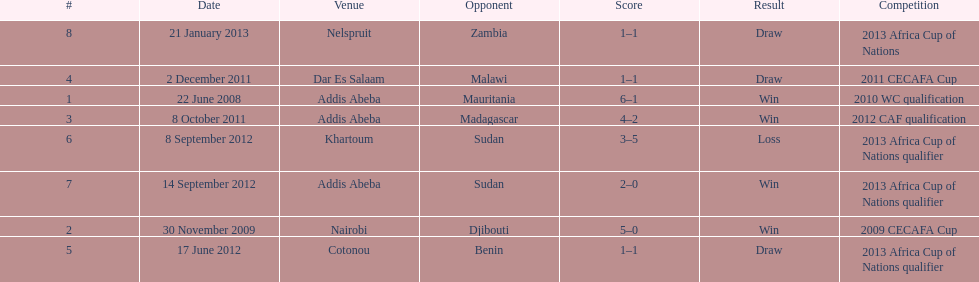How long in years down this table cover? 5. 